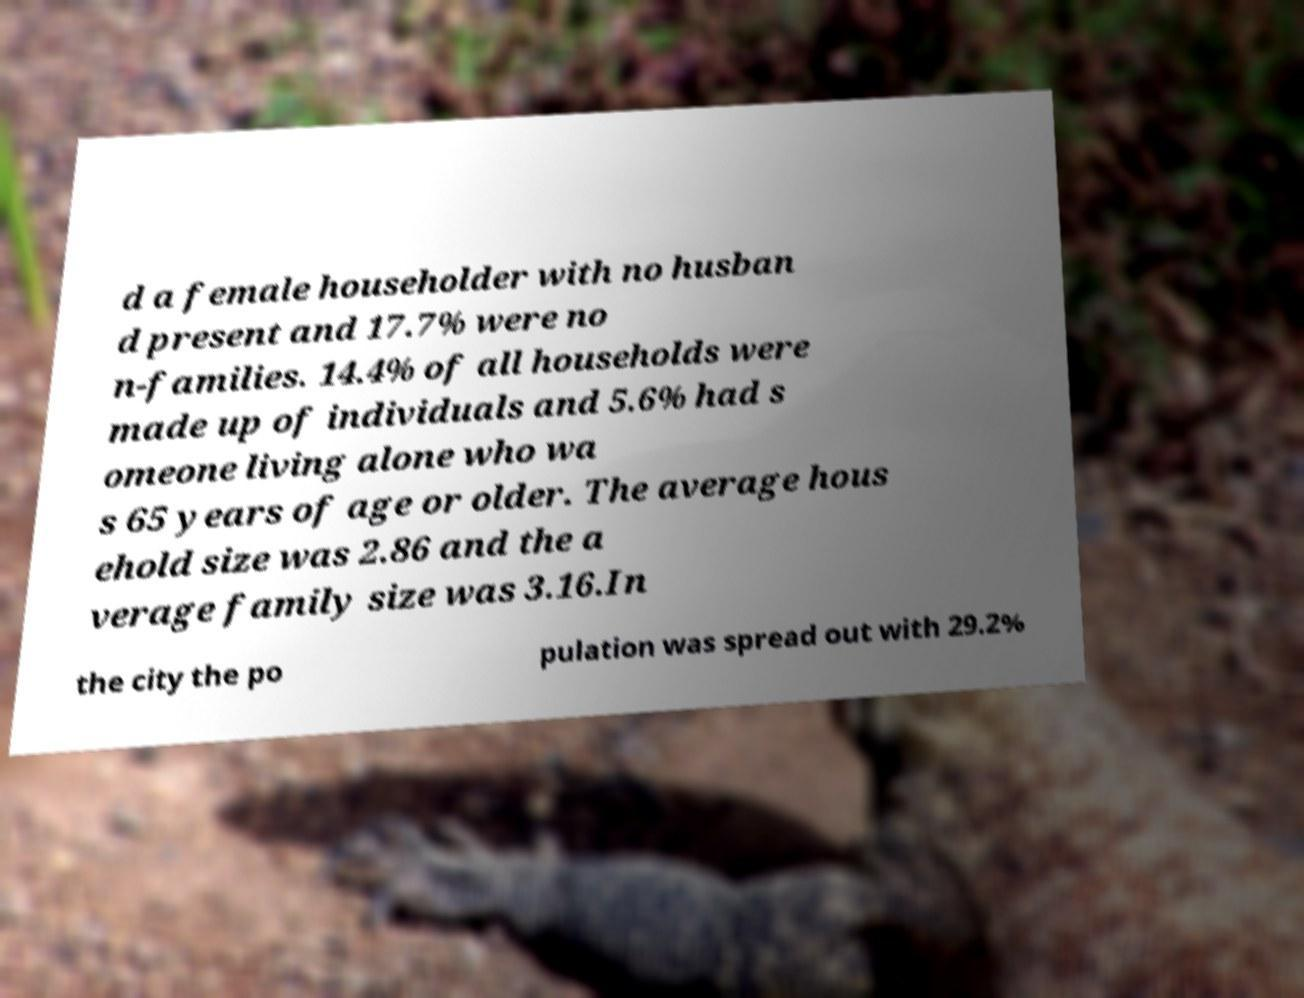Can you read and provide the text displayed in the image?This photo seems to have some interesting text. Can you extract and type it out for me? d a female householder with no husban d present and 17.7% were no n-families. 14.4% of all households were made up of individuals and 5.6% had s omeone living alone who wa s 65 years of age or older. The average hous ehold size was 2.86 and the a verage family size was 3.16.In the city the po pulation was spread out with 29.2% 